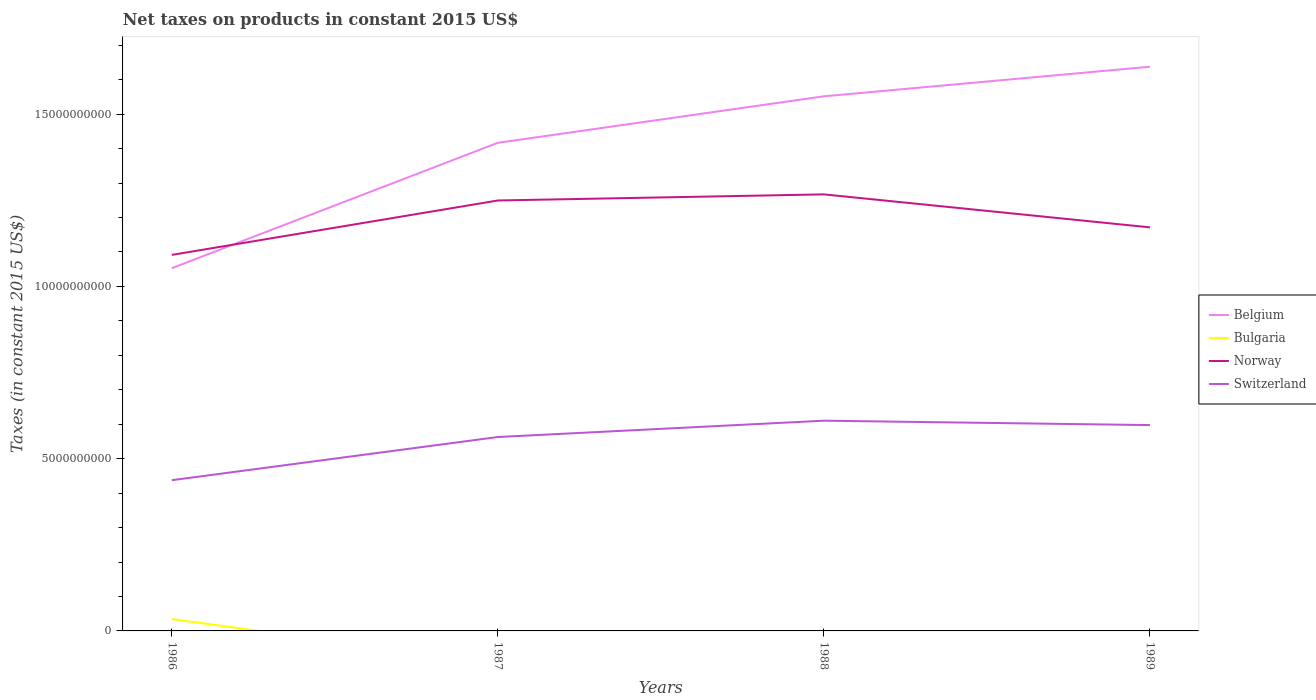How many different coloured lines are there?
Your answer should be compact. 4. Is the number of lines equal to the number of legend labels?
Offer a very short reply. No. Across all years, what is the maximum net taxes on products in Switzerland?
Your response must be concise. 4.37e+09. What is the total net taxes on products in Switzerland in the graph?
Your answer should be very brief. -1.60e+09. What is the difference between the highest and the second highest net taxes on products in Norway?
Offer a very short reply. 1.76e+09. What is the difference between the highest and the lowest net taxes on products in Belgium?
Offer a terse response. 3. Is the net taxes on products in Norway strictly greater than the net taxes on products in Belgium over the years?
Your answer should be compact. No. How many years are there in the graph?
Your answer should be very brief. 4. What is the difference between two consecutive major ticks on the Y-axis?
Offer a terse response. 5.00e+09. Does the graph contain any zero values?
Keep it short and to the point. Yes. Where does the legend appear in the graph?
Offer a very short reply. Center right. How many legend labels are there?
Your answer should be compact. 4. How are the legend labels stacked?
Your answer should be compact. Vertical. What is the title of the graph?
Offer a terse response. Net taxes on products in constant 2015 US$. What is the label or title of the X-axis?
Make the answer very short. Years. What is the label or title of the Y-axis?
Make the answer very short. Taxes (in constant 2015 US$). What is the Taxes (in constant 2015 US$) in Belgium in 1986?
Ensure brevity in your answer.  1.05e+1. What is the Taxes (in constant 2015 US$) in Bulgaria in 1986?
Give a very brief answer. 3.45e+08. What is the Taxes (in constant 2015 US$) in Norway in 1986?
Keep it short and to the point. 1.09e+1. What is the Taxes (in constant 2015 US$) of Switzerland in 1986?
Ensure brevity in your answer.  4.37e+09. What is the Taxes (in constant 2015 US$) in Belgium in 1987?
Offer a very short reply. 1.42e+1. What is the Taxes (in constant 2015 US$) of Bulgaria in 1987?
Your answer should be very brief. 0. What is the Taxes (in constant 2015 US$) of Norway in 1987?
Ensure brevity in your answer.  1.25e+1. What is the Taxes (in constant 2015 US$) of Switzerland in 1987?
Offer a terse response. 5.63e+09. What is the Taxes (in constant 2015 US$) of Belgium in 1988?
Make the answer very short. 1.55e+1. What is the Taxes (in constant 2015 US$) of Bulgaria in 1988?
Your answer should be compact. 0. What is the Taxes (in constant 2015 US$) in Norway in 1988?
Your answer should be very brief. 1.27e+1. What is the Taxes (in constant 2015 US$) of Switzerland in 1988?
Keep it short and to the point. 6.10e+09. What is the Taxes (in constant 2015 US$) of Belgium in 1989?
Keep it short and to the point. 1.64e+1. What is the Taxes (in constant 2015 US$) of Bulgaria in 1989?
Provide a short and direct response. 0. What is the Taxes (in constant 2015 US$) in Norway in 1989?
Provide a short and direct response. 1.17e+1. What is the Taxes (in constant 2015 US$) of Switzerland in 1989?
Your answer should be compact. 5.97e+09. Across all years, what is the maximum Taxes (in constant 2015 US$) in Belgium?
Provide a succinct answer. 1.64e+1. Across all years, what is the maximum Taxes (in constant 2015 US$) of Bulgaria?
Provide a short and direct response. 3.45e+08. Across all years, what is the maximum Taxes (in constant 2015 US$) in Norway?
Keep it short and to the point. 1.27e+1. Across all years, what is the maximum Taxes (in constant 2015 US$) in Switzerland?
Keep it short and to the point. 6.10e+09. Across all years, what is the minimum Taxes (in constant 2015 US$) of Belgium?
Make the answer very short. 1.05e+1. Across all years, what is the minimum Taxes (in constant 2015 US$) in Bulgaria?
Offer a terse response. 0. Across all years, what is the minimum Taxes (in constant 2015 US$) of Norway?
Provide a succinct answer. 1.09e+1. Across all years, what is the minimum Taxes (in constant 2015 US$) in Switzerland?
Provide a succinct answer. 4.37e+09. What is the total Taxes (in constant 2015 US$) in Belgium in the graph?
Offer a very short reply. 5.66e+1. What is the total Taxes (in constant 2015 US$) of Bulgaria in the graph?
Make the answer very short. 3.45e+08. What is the total Taxes (in constant 2015 US$) in Norway in the graph?
Provide a succinct answer. 4.78e+1. What is the total Taxes (in constant 2015 US$) of Switzerland in the graph?
Offer a terse response. 2.21e+1. What is the difference between the Taxes (in constant 2015 US$) in Belgium in 1986 and that in 1987?
Offer a terse response. -3.64e+09. What is the difference between the Taxes (in constant 2015 US$) of Norway in 1986 and that in 1987?
Make the answer very short. -1.58e+09. What is the difference between the Taxes (in constant 2015 US$) of Switzerland in 1986 and that in 1987?
Offer a very short reply. -1.25e+09. What is the difference between the Taxes (in constant 2015 US$) in Belgium in 1986 and that in 1988?
Keep it short and to the point. -4.99e+09. What is the difference between the Taxes (in constant 2015 US$) of Norway in 1986 and that in 1988?
Your answer should be very brief. -1.76e+09. What is the difference between the Taxes (in constant 2015 US$) in Switzerland in 1986 and that in 1988?
Offer a terse response. -1.73e+09. What is the difference between the Taxes (in constant 2015 US$) of Belgium in 1986 and that in 1989?
Offer a terse response. -5.85e+09. What is the difference between the Taxes (in constant 2015 US$) in Norway in 1986 and that in 1989?
Provide a succinct answer. -7.99e+08. What is the difference between the Taxes (in constant 2015 US$) in Switzerland in 1986 and that in 1989?
Ensure brevity in your answer.  -1.60e+09. What is the difference between the Taxes (in constant 2015 US$) of Belgium in 1987 and that in 1988?
Your answer should be compact. -1.35e+09. What is the difference between the Taxes (in constant 2015 US$) in Norway in 1987 and that in 1988?
Give a very brief answer. -1.78e+08. What is the difference between the Taxes (in constant 2015 US$) in Switzerland in 1987 and that in 1988?
Your response must be concise. -4.74e+08. What is the difference between the Taxes (in constant 2015 US$) of Belgium in 1987 and that in 1989?
Provide a short and direct response. -2.21e+09. What is the difference between the Taxes (in constant 2015 US$) in Norway in 1987 and that in 1989?
Keep it short and to the point. 7.80e+08. What is the difference between the Taxes (in constant 2015 US$) in Switzerland in 1987 and that in 1989?
Your answer should be compact. -3.46e+08. What is the difference between the Taxes (in constant 2015 US$) in Belgium in 1988 and that in 1989?
Provide a short and direct response. -8.58e+08. What is the difference between the Taxes (in constant 2015 US$) in Norway in 1988 and that in 1989?
Make the answer very short. 9.58e+08. What is the difference between the Taxes (in constant 2015 US$) in Switzerland in 1988 and that in 1989?
Your response must be concise. 1.28e+08. What is the difference between the Taxes (in constant 2015 US$) of Belgium in 1986 and the Taxes (in constant 2015 US$) of Norway in 1987?
Provide a short and direct response. -1.96e+09. What is the difference between the Taxes (in constant 2015 US$) of Belgium in 1986 and the Taxes (in constant 2015 US$) of Switzerland in 1987?
Give a very brief answer. 4.90e+09. What is the difference between the Taxes (in constant 2015 US$) of Bulgaria in 1986 and the Taxes (in constant 2015 US$) of Norway in 1987?
Keep it short and to the point. -1.21e+1. What is the difference between the Taxes (in constant 2015 US$) of Bulgaria in 1986 and the Taxes (in constant 2015 US$) of Switzerland in 1987?
Give a very brief answer. -5.28e+09. What is the difference between the Taxes (in constant 2015 US$) in Norway in 1986 and the Taxes (in constant 2015 US$) in Switzerland in 1987?
Offer a terse response. 5.29e+09. What is the difference between the Taxes (in constant 2015 US$) of Belgium in 1986 and the Taxes (in constant 2015 US$) of Norway in 1988?
Give a very brief answer. -2.14e+09. What is the difference between the Taxes (in constant 2015 US$) in Belgium in 1986 and the Taxes (in constant 2015 US$) in Switzerland in 1988?
Your answer should be compact. 4.43e+09. What is the difference between the Taxes (in constant 2015 US$) of Bulgaria in 1986 and the Taxes (in constant 2015 US$) of Norway in 1988?
Offer a very short reply. -1.23e+1. What is the difference between the Taxes (in constant 2015 US$) of Bulgaria in 1986 and the Taxes (in constant 2015 US$) of Switzerland in 1988?
Offer a very short reply. -5.76e+09. What is the difference between the Taxes (in constant 2015 US$) in Norway in 1986 and the Taxes (in constant 2015 US$) in Switzerland in 1988?
Offer a very short reply. 4.81e+09. What is the difference between the Taxes (in constant 2015 US$) of Belgium in 1986 and the Taxes (in constant 2015 US$) of Norway in 1989?
Your response must be concise. -1.18e+09. What is the difference between the Taxes (in constant 2015 US$) of Belgium in 1986 and the Taxes (in constant 2015 US$) of Switzerland in 1989?
Provide a short and direct response. 4.55e+09. What is the difference between the Taxes (in constant 2015 US$) in Bulgaria in 1986 and the Taxes (in constant 2015 US$) in Norway in 1989?
Provide a short and direct response. -1.14e+1. What is the difference between the Taxes (in constant 2015 US$) in Bulgaria in 1986 and the Taxes (in constant 2015 US$) in Switzerland in 1989?
Provide a succinct answer. -5.63e+09. What is the difference between the Taxes (in constant 2015 US$) in Norway in 1986 and the Taxes (in constant 2015 US$) in Switzerland in 1989?
Your answer should be very brief. 4.94e+09. What is the difference between the Taxes (in constant 2015 US$) of Belgium in 1987 and the Taxes (in constant 2015 US$) of Norway in 1988?
Give a very brief answer. 1.50e+09. What is the difference between the Taxes (in constant 2015 US$) of Belgium in 1987 and the Taxes (in constant 2015 US$) of Switzerland in 1988?
Offer a very short reply. 8.07e+09. What is the difference between the Taxes (in constant 2015 US$) of Norway in 1987 and the Taxes (in constant 2015 US$) of Switzerland in 1988?
Your response must be concise. 6.39e+09. What is the difference between the Taxes (in constant 2015 US$) of Belgium in 1987 and the Taxes (in constant 2015 US$) of Norway in 1989?
Offer a very short reply. 2.45e+09. What is the difference between the Taxes (in constant 2015 US$) in Belgium in 1987 and the Taxes (in constant 2015 US$) in Switzerland in 1989?
Keep it short and to the point. 8.19e+09. What is the difference between the Taxes (in constant 2015 US$) in Norway in 1987 and the Taxes (in constant 2015 US$) in Switzerland in 1989?
Your answer should be very brief. 6.52e+09. What is the difference between the Taxes (in constant 2015 US$) in Belgium in 1988 and the Taxes (in constant 2015 US$) in Norway in 1989?
Provide a short and direct response. 3.80e+09. What is the difference between the Taxes (in constant 2015 US$) of Belgium in 1988 and the Taxes (in constant 2015 US$) of Switzerland in 1989?
Offer a very short reply. 9.54e+09. What is the difference between the Taxes (in constant 2015 US$) in Norway in 1988 and the Taxes (in constant 2015 US$) in Switzerland in 1989?
Make the answer very short. 6.70e+09. What is the average Taxes (in constant 2015 US$) of Belgium per year?
Offer a terse response. 1.41e+1. What is the average Taxes (in constant 2015 US$) of Bulgaria per year?
Provide a succinct answer. 8.61e+07. What is the average Taxes (in constant 2015 US$) in Norway per year?
Give a very brief answer. 1.19e+1. What is the average Taxes (in constant 2015 US$) of Switzerland per year?
Provide a succinct answer. 5.52e+09. In the year 1986, what is the difference between the Taxes (in constant 2015 US$) in Belgium and Taxes (in constant 2015 US$) in Bulgaria?
Your response must be concise. 1.02e+1. In the year 1986, what is the difference between the Taxes (in constant 2015 US$) in Belgium and Taxes (in constant 2015 US$) in Norway?
Your response must be concise. -3.85e+08. In the year 1986, what is the difference between the Taxes (in constant 2015 US$) in Belgium and Taxes (in constant 2015 US$) in Switzerland?
Offer a very short reply. 6.15e+09. In the year 1986, what is the difference between the Taxes (in constant 2015 US$) of Bulgaria and Taxes (in constant 2015 US$) of Norway?
Give a very brief answer. -1.06e+1. In the year 1986, what is the difference between the Taxes (in constant 2015 US$) of Bulgaria and Taxes (in constant 2015 US$) of Switzerland?
Make the answer very short. -4.03e+09. In the year 1986, what is the difference between the Taxes (in constant 2015 US$) in Norway and Taxes (in constant 2015 US$) in Switzerland?
Give a very brief answer. 6.54e+09. In the year 1987, what is the difference between the Taxes (in constant 2015 US$) of Belgium and Taxes (in constant 2015 US$) of Norway?
Provide a short and direct response. 1.67e+09. In the year 1987, what is the difference between the Taxes (in constant 2015 US$) of Belgium and Taxes (in constant 2015 US$) of Switzerland?
Your answer should be very brief. 8.54e+09. In the year 1987, what is the difference between the Taxes (in constant 2015 US$) of Norway and Taxes (in constant 2015 US$) of Switzerland?
Make the answer very short. 6.87e+09. In the year 1988, what is the difference between the Taxes (in constant 2015 US$) of Belgium and Taxes (in constant 2015 US$) of Norway?
Your response must be concise. 2.85e+09. In the year 1988, what is the difference between the Taxes (in constant 2015 US$) in Belgium and Taxes (in constant 2015 US$) in Switzerland?
Offer a very short reply. 9.42e+09. In the year 1988, what is the difference between the Taxes (in constant 2015 US$) of Norway and Taxes (in constant 2015 US$) of Switzerland?
Offer a terse response. 6.57e+09. In the year 1989, what is the difference between the Taxes (in constant 2015 US$) of Belgium and Taxes (in constant 2015 US$) of Norway?
Offer a very short reply. 4.66e+09. In the year 1989, what is the difference between the Taxes (in constant 2015 US$) of Belgium and Taxes (in constant 2015 US$) of Switzerland?
Your answer should be compact. 1.04e+1. In the year 1989, what is the difference between the Taxes (in constant 2015 US$) in Norway and Taxes (in constant 2015 US$) in Switzerland?
Provide a short and direct response. 5.74e+09. What is the ratio of the Taxes (in constant 2015 US$) of Belgium in 1986 to that in 1987?
Ensure brevity in your answer.  0.74. What is the ratio of the Taxes (in constant 2015 US$) of Norway in 1986 to that in 1987?
Offer a terse response. 0.87. What is the ratio of the Taxes (in constant 2015 US$) in Switzerland in 1986 to that in 1987?
Offer a terse response. 0.78. What is the ratio of the Taxes (in constant 2015 US$) in Belgium in 1986 to that in 1988?
Keep it short and to the point. 0.68. What is the ratio of the Taxes (in constant 2015 US$) in Norway in 1986 to that in 1988?
Offer a very short reply. 0.86. What is the ratio of the Taxes (in constant 2015 US$) in Switzerland in 1986 to that in 1988?
Give a very brief answer. 0.72. What is the ratio of the Taxes (in constant 2015 US$) of Belgium in 1986 to that in 1989?
Offer a terse response. 0.64. What is the ratio of the Taxes (in constant 2015 US$) of Norway in 1986 to that in 1989?
Your response must be concise. 0.93. What is the ratio of the Taxes (in constant 2015 US$) of Switzerland in 1986 to that in 1989?
Offer a terse response. 0.73. What is the ratio of the Taxes (in constant 2015 US$) in Belgium in 1987 to that in 1988?
Give a very brief answer. 0.91. What is the ratio of the Taxes (in constant 2015 US$) of Norway in 1987 to that in 1988?
Make the answer very short. 0.99. What is the ratio of the Taxes (in constant 2015 US$) in Switzerland in 1987 to that in 1988?
Give a very brief answer. 0.92. What is the ratio of the Taxes (in constant 2015 US$) in Belgium in 1987 to that in 1989?
Your answer should be compact. 0.87. What is the ratio of the Taxes (in constant 2015 US$) of Norway in 1987 to that in 1989?
Provide a short and direct response. 1.07. What is the ratio of the Taxes (in constant 2015 US$) of Switzerland in 1987 to that in 1989?
Your answer should be compact. 0.94. What is the ratio of the Taxes (in constant 2015 US$) in Belgium in 1988 to that in 1989?
Your answer should be very brief. 0.95. What is the ratio of the Taxes (in constant 2015 US$) of Norway in 1988 to that in 1989?
Give a very brief answer. 1.08. What is the ratio of the Taxes (in constant 2015 US$) of Switzerland in 1988 to that in 1989?
Offer a very short reply. 1.02. What is the difference between the highest and the second highest Taxes (in constant 2015 US$) in Belgium?
Offer a terse response. 8.58e+08. What is the difference between the highest and the second highest Taxes (in constant 2015 US$) in Norway?
Your answer should be very brief. 1.78e+08. What is the difference between the highest and the second highest Taxes (in constant 2015 US$) of Switzerland?
Provide a short and direct response. 1.28e+08. What is the difference between the highest and the lowest Taxes (in constant 2015 US$) of Belgium?
Offer a terse response. 5.85e+09. What is the difference between the highest and the lowest Taxes (in constant 2015 US$) of Bulgaria?
Offer a very short reply. 3.45e+08. What is the difference between the highest and the lowest Taxes (in constant 2015 US$) in Norway?
Ensure brevity in your answer.  1.76e+09. What is the difference between the highest and the lowest Taxes (in constant 2015 US$) of Switzerland?
Provide a succinct answer. 1.73e+09. 